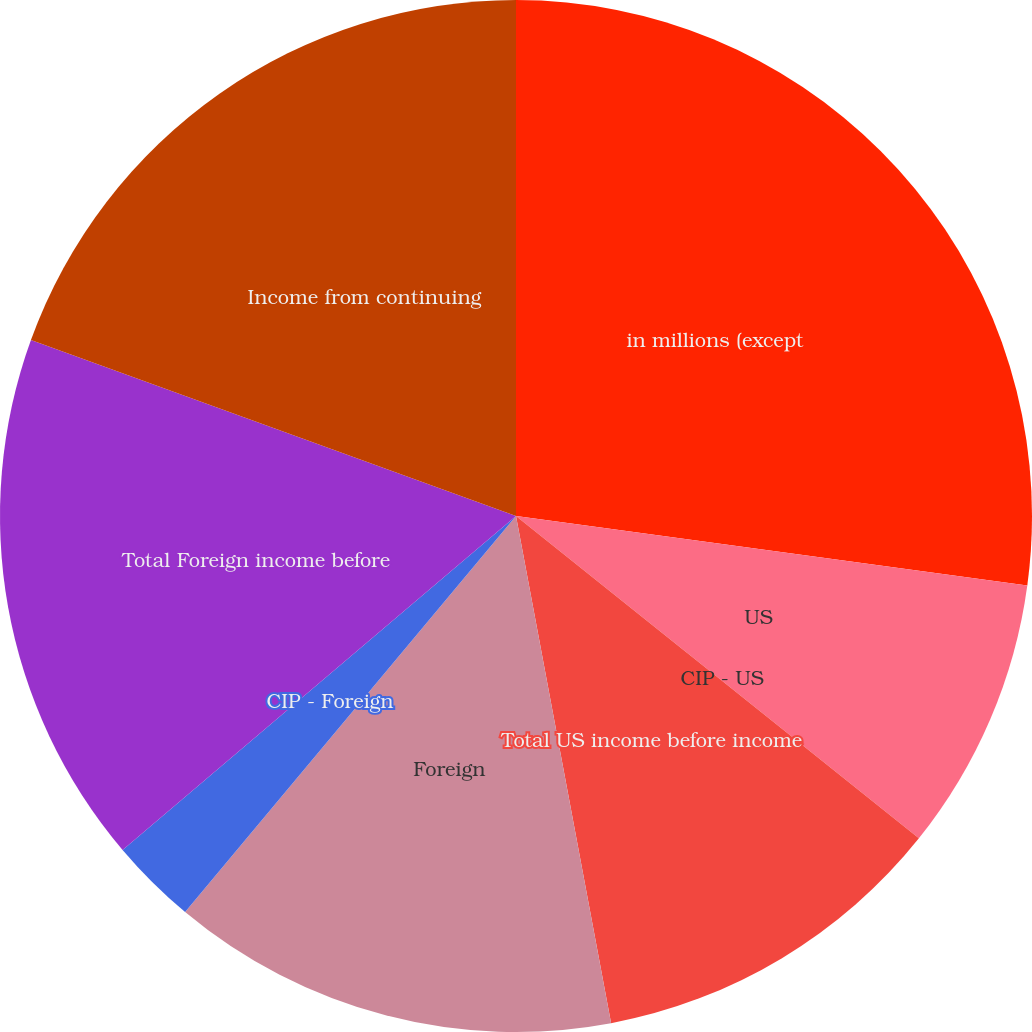Convert chart to OTSL. <chart><loc_0><loc_0><loc_500><loc_500><pie_chart><fcel>in millions (except<fcel>US<fcel>CIP - US<fcel>Total US income before income<fcel>Foreign<fcel>CIP - Foreign<fcel>Total Foreign income before<fcel>Income from continuing<nl><fcel>27.15%<fcel>8.59%<fcel>0.0%<fcel>11.31%<fcel>14.03%<fcel>2.72%<fcel>16.74%<fcel>19.46%<nl></chart> 